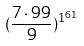Convert formula to latex. <formula><loc_0><loc_0><loc_500><loc_500>( \frac { 7 \cdot 9 9 } { 9 } ) ^ { 1 ^ { 6 1 } }</formula> 